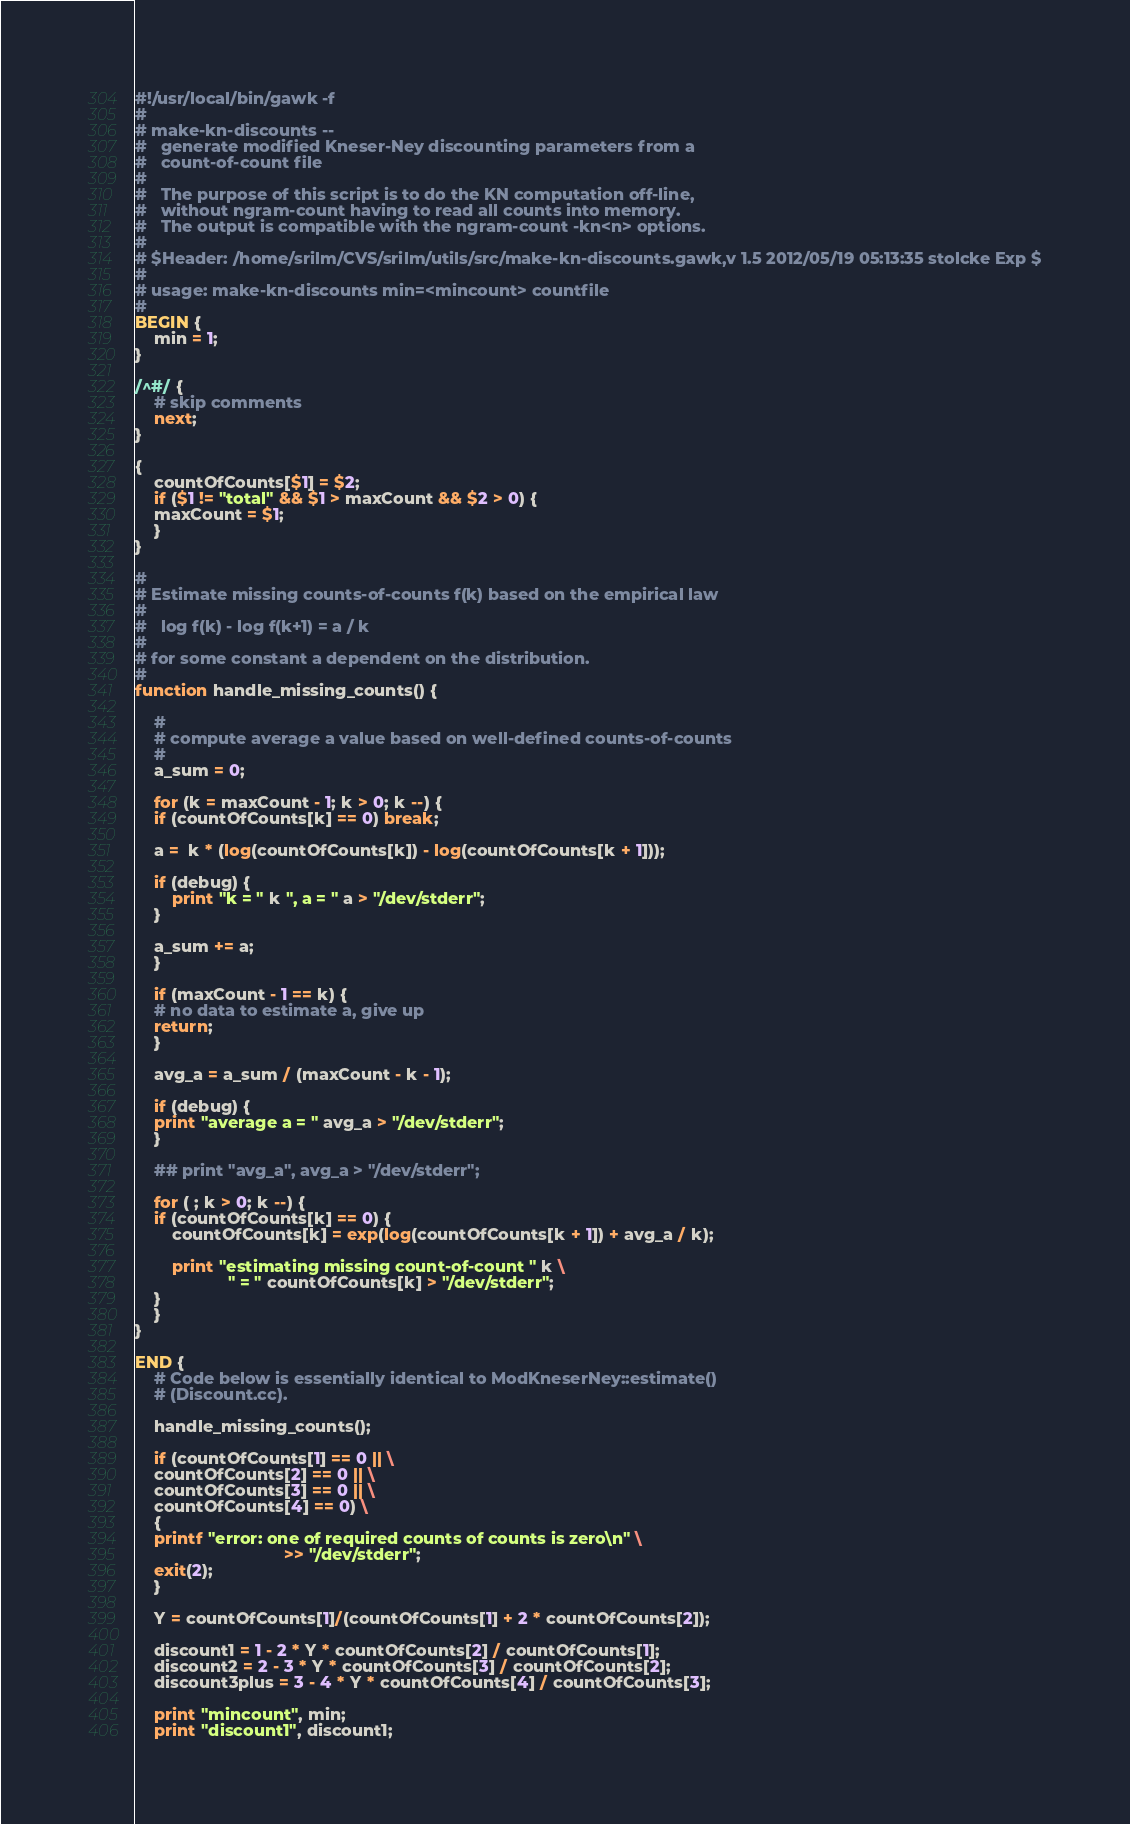<code> <loc_0><loc_0><loc_500><loc_500><_Awk_>#!/usr/local/bin/gawk -f
#
# make-kn-discounts --
#	generate modified Kneser-Ney discounting parameters from a
#	count-of-count file
#
#	The purpose of this script is to do the KN computation off-line,
#	without ngram-count having to read all counts into memory.
#	The output is compatible with the ngram-count -kn<n> options.
#
# $Header: /home/srilm/CVS/srilm/utils/src/make-kn-discounts.gawk,v 1.5 2012/05/19 05:13:35 stolcke Exp $
#
# usage: make-kn-discounts min=<mincount> countfile
#
BEGIN {
    min = 1;
}

/^#/ {
    # skip comments
    next;
}

{
    countOfCounts[$1] = $2;
    if ($1 != "total" && $1 > maxCount && $2 > 0) {
	maxCount = $1;
    }
}

#
# Estimate missing counts-of-counts f(k) based on the empirical law
#
#	log f(k) - log f(k+1) = a / k
#
# for some constant a dependent on the distribution.
#
function handle_missing_counts() {

    #
    # compute average a value based on well-defined counts-of-counts
    #
    a_sum = 0;

    for (k = maxCount - 1; k > 0; k --) {
	if (countOfCounts[k] == 0) break;

	a =  k * (log(countOfCounts[k]) - log(countOfCounts[k + 1]));

	if (debug) {
		print "k = " k ", a = " a > "/dev/stderr";
	}

	a_sum += a;
    }

    if (maxCount - 1 == k) {
	# no data to estimate a, give up
	return;
    }

    avg_a = a_sum / (maxCount - k - 1);

    if (debug) {
	print "average a = " avg_a > "/dev/stderr";
    }

    ## print "avg_a", avg_a > "/dev/stderr";

    for ( ; k > 0; k --) {
	if (countOfCounts[k] == 0) {
	    countOfCounts[k] = exp(log(countOfCounts[k + 1]) + avg_a / k);

	    print "estimating missing count-of-count " k \
					" = " countOfCounts[k] > "/dev/stderr";
	}
    }
}

END {
    # Code below is essentially identical to ModKneserNey::estimate()
    # (Discount.cc).

    handle_missing_counts();

    if (countOfCounts[1] == 0 || \
	countOfCounts[2] == 0 || \
	countOfCounts[3] == 0 || \
	countOfCounts[4] == 0) \
    {
	printf "error: one of required counts of counts is zero\n" \
	       						>> "/dev/stderr";
	exit(2);
    }

    Y = countOfCounts[1]/(countOfCounts[1] + 2 * countOfCounts[2]);

    discount1 = 1 - 2 * Y * countOfCounts[2] / countOfCounts[1];
    discount2 = 2 - 3 * Y * countOfCounts[3] / countOfCounts[2];
    discount3plus = 3 - 4 * Y * countOfCounts[4] / countOfCounts[3];

    print "mincount", min;
    print "discount1", discount1;</code> 